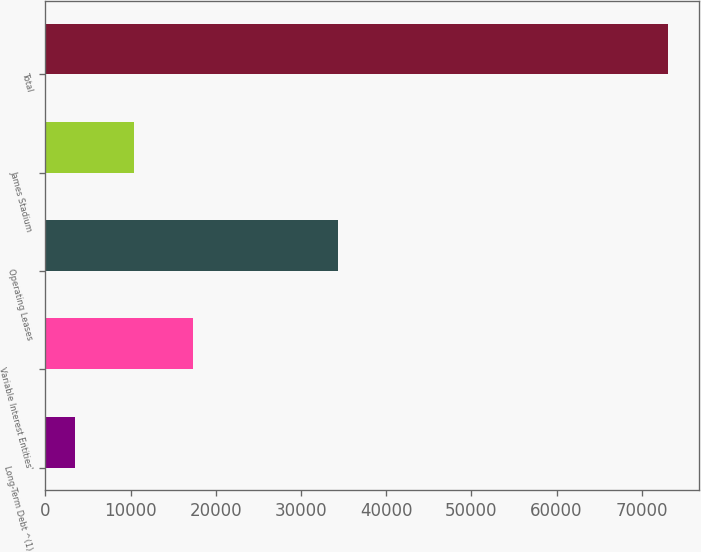Convert chart. <chart><loc_0><loc_0><loc_500><loc_500><bar_chart><fcel>Long-Term Debt ^(1)<fcel>Variable Interest Entities'<fcel>Operating Leases<fcel>James Stadium<fcel>Total<nl><fcel>3445<fcel>17379.8<fcel>34403<fcel>10412.4<fcel>73119<nl></chart> 